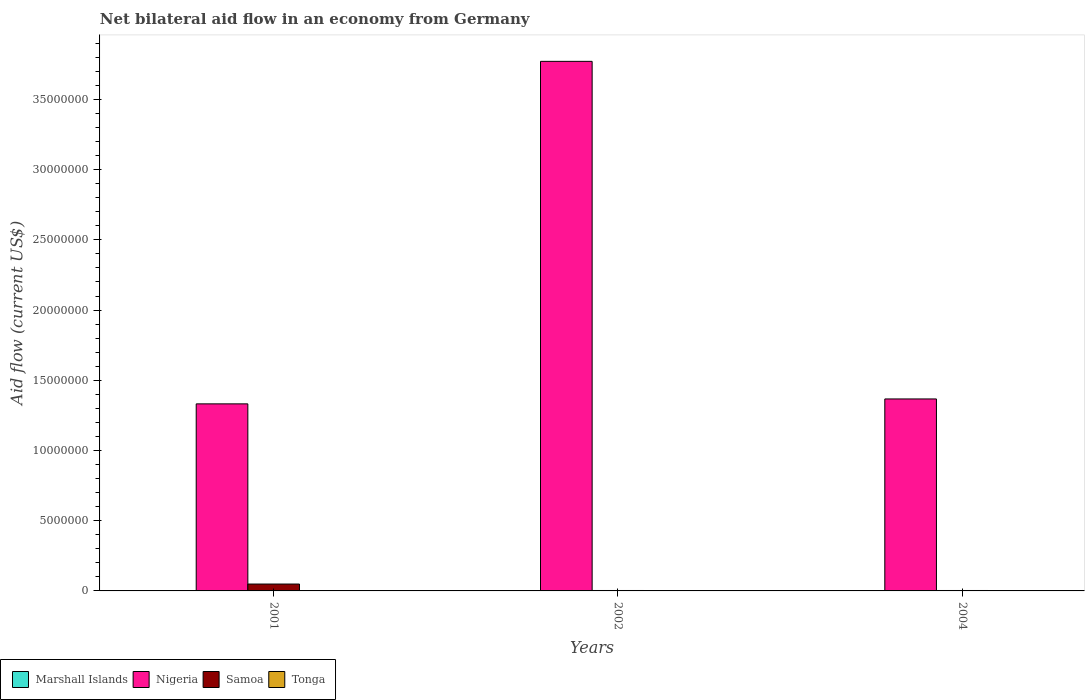How many groups of bars are there?
Provide a succinct answer. 3. Are the number of bars on each tick of the X-axis equal?
Offer a terse response. Yes. How many bars are there on the 2nd tick from the left?
Offer a terse response. 3. How many bars are there on the 2nd tick from the right?
Keep it short and to the point. 3. What is the net bilateral aid flow in Samoa in 2002?
Ensure brevity in your answer.  3.00e+04. In which year was the net bilateral aid flow in Marshall Islands maximum?
Provide a succinct answer. 2001. What is the total net bilateral aid flow in Tonga in the graph?
Your answer should be compact. 0. What is the average net bilateral aid flow in Marshall Islands per year?
Your answer should be very brief. 10000. In the year 2002, what is the difference between the net bilateral aid flow in Nigeria and net bilateral aid flow in Marshall Islands?
Your answer should be compact. 3.77e+07. What is the ratio of the net bilateral aid flow in Samoa in 2001 to that in 2002?
Provide a short and direct response. 16.33. What is the difference between the highest and the second highest net bilateral aid flow in Marshall Islands?
Ensure brevity in your answer.  0. What is the difference between the highest and the lowest net bilateral aid flow in Marshall Islands?
Your answer should be very brief. 0. In how many years, is the net bilateral aid flow in Marshall Islands greater than the average net bilateral aid flow in Marshall Islands taken over all years?
Make the answer very short. 0. Is it the case that in every year, the sum of the net bilateral aid flow in Marshall Islands and net bilateral aid flow in Tonga is greater than the sum of net bilateral aid flow in Samoa and net bilateral aid flow in Nigeria?
Provide a succinct answer. No. Is it the case that in every year, the sum of the net bilateral aid flow in Marshall Islands and net bilateral aid flow in Samoa is greater than the net bilateral aid flow in Tonga?
Provide a short and direct response. Yes. How many bars are there?
Provide a short and direct response. 9. Are all the bars in the graph horizontal?
Your answer should be very brief. No. Are the values on the major ticks of Y-axis written in scientific E-notation?
Your answer should be compact. No. Does the graph contain any zero values?
Your answer should be compact. Yes. Does the graph contain grids?
Offer a very short reply. No. Where does the legend appear in the graph?
Your answer should be compact. Bottom left. How are the legend labels stacked?
Offer a terse response. Horizontal. What is the title of the graph?
Keep it short and to the point. Net bilateral aid flow in an economy from Germany. Does "Grenada" appear as one of the legend labels in the graph?
Offer a very short reply. No. What is the label or title of the X-axis?
Offer a terse response. Years. What is the Aid flow (current US$) in Nigeria in 2001?
Offer a terse response. 1.33e+07. What is the Aid flow (current US$) of Tonga in 2001?
Offer a very short reply. 0. What is the Aid flow (current US$) in Nigeria in 2002?
Ensure brevity in your answer.  3.77e+07. What is the Aid flow (current US$) of Tonga in 2002?
Your answer should be compact. 0. What is the Aid flow (current US$) of Nigeria in 2004?
Your answer should be very brief. 1.37e+07. What is the Aid flow (current US$) in Tonga in 2004?
Provide a short and direct response. 0. Across all years, what is the maximum Aid flow (current US$) in Nigeria?
Your response must be concise. 3.77e+07. Across all years, what is the minimum Aid flow (current US$) of Marshall Islands?
Give a very brief answer. 10000. Across all years, what is the minimum Aid flow (current US$) of Nigeria?
Make the answer very short. 1.33e+07. What is the total Aid flow (current US$) in Marshall Islands in the graph?
Ensure brevity in your answer.  3.00e+04. What is the total Aid flow (current US$) of Nigeria in the graph?
Give a very brief answer. 6.47e+07. What is the total Aid flow (current US$) of Samoa in the graph?
Give a very brief answer. 5.50e+05. What is the difference between the Aid flow (current US$) in Marshall Islands in 2001 and that in 2002?
Your answer should be compact. 0. What is the difference between the Aid flow (current US$) in Nigeria in 2001 and that in 2002?
Your answer should be compact. -2.44e+07. What is the difference between the Aid flow (current US$) in Nigeria in 2001 and that in 2004?
Your answer should be compact. -3.50e+05. What is the difference between the Aid flow (current US$) in Nigeria in 2002 and that in 2004?
Offer a very short reply. 2.40e+07. What is the difference between the Aid flow (current US$) in Marshall Islands in 2001 and the Aid flow (current US$) in Nigeria in 2002?
Keep it short and to the point. -3.77e+07. What is the difference between the Aid flow (current US$) in Marshall Islands in 2001 and the Aid flow (current US$) in Samoa in 2002?
Provide a succinct answer. -2.00e+04. What is the difference between the Aid flow (current US$) in Nigeria in 2001 and the Aid flow (current US$) in Samoa in 2002?
Make the answer very short. 1.33e+07. What is the difference between the Aid flow (current US$) of Marshall Islands in 2001 and the Aid flow (current US$) of Nigeria in 2004?
Provide a succinct answer. -1.37e+07. What is the difference between the Aid flow (current US$) in Nigeria in 2001 and the Aid flow (current US$) in Samoa in 2004?
Your answer should be very brief. 1.33e+07. What is the difference between the Aid flow (current US$) of Marshall Islands in 2002 and the Aid flow (current US$) of Nigeria in 2004?
Offer a terse response. -1.37e+07. What is the difference between the Aid flow (current US$) in Nigeria in 2002 and the Aid flow (current US$) in Samoa in 2004?
Your answer should be compact. 3.77e+07. What is the average Aid flow (current US$) of Nigeria per year?
Give a very brief answer. 2.16e+07. What is the average Aid flow (current US$) of Samoa per year?
Your answer should be very brief. 1.83e+05. In the year 2001, what is the difference between the Aid flow (current US$) in Marshall Islands and Aid flow (current US$) in Nigeria?
Your answer should be very brief. -1.33e+07. In the year 2001, what is the difference between the Aid flow (current US$) of Marshall Islands and Aid flow (current US$) of Samoa?
Your answer should be very brief. -4.80e+05. In the year 2001, what is the difference between the Aid flow (current US$) in Nigeria and Aid flow (current US$) in Samoa?
Your answer should be very brief. 1.28e+07. In the year 2002, what is the difference between the Aid flow (current US$) in Marshall Islands and Aid flow (current US$) in Nigeria?
Offer a terse response. -3.77e+07. In the year 2002, what is the difference between the Aid flow (current US$) in Marshall Islands and Aid flow (current US$) in Samoa?
Your answer should be very brief. -2.00e+04. In the year 2002, what is the difference between the Aid flow (current US$) of Nigeria and Aid flow (current US$) of Samoa?
Offer a terse response. 3.77e+07. In the year 2004, what is the difference between the Aid flow (current US$) in Marshall Islands and Aid flow (current US$) in Nigeria?
Keep it short and to the point. -1.37e+07. In the year 2004, what is the difference between the Aid flow (current US$) of Marshall Islands and Aid flow (current US$) of Samoa?
Offer a terse response. -2.00e+04. In the year 2004, what is the difference between the Aid flow (current US$) of Nigeria and Aid flow (current US$) of Samoa?
Your answer should be very brief. 1.36e+07. What is the ratio of the Aid flow (current US$) in Marshall Islands in 2001 to that in 2002?
Offer a very short reply. 1. What is the ratio of the Aid flow (current US$) of Nigeria in 2001 to that in 2002?
Give a very brief answer. 0.35. What is the ratio of the Aid flow (current US$) of Samoa in 2001 to that in 2002?
Keep it short and to the point. 16.33. What is the ratio of the Aid flow (current US$) of Marshall Islands in 2001 to that in 2004?
Your answer should be compact. 1. What is the ratio of the Aid flow (current US$) of Nigeria in 2001 to that in 2004?
Your response must be concise. 0.97. What is the ratio of the Aid flow (current US$) of Samoa in 2001 to that in 2004?
Provide a succinct answer. 16.33. What is the ratio of the Aid flow (current US$) of Nigeria in 2002 to that in 2004?
Provide a succinct answer. 2.76. What is the difference between the highest and the second highest Aid flow (current US$) in Marshall Islands?
Offer a terse response. 0. What is the difference between the highest and the second highest Aid flow (current US$) in Nigeria?
Provide a succinct answer. 2.40e+07. What is the difference between the highest and the second highest Aid flow (current US$) of Samoa?
Your answer should be very brief. 4.60e+05. What is the difference between the highest and the lowest Aid flow (current US$) in Marshall Islands?
Your answer should be compact. 0. What is the difference between the highest and the lowest Aid flow (current US$) of Nigeria?
Your response must be concise. 2.44e+07. What is the difference between the highest and the lowest Aid flow (current US$) in Samoa?
Provide a short and direct response. 4.60e+05. 